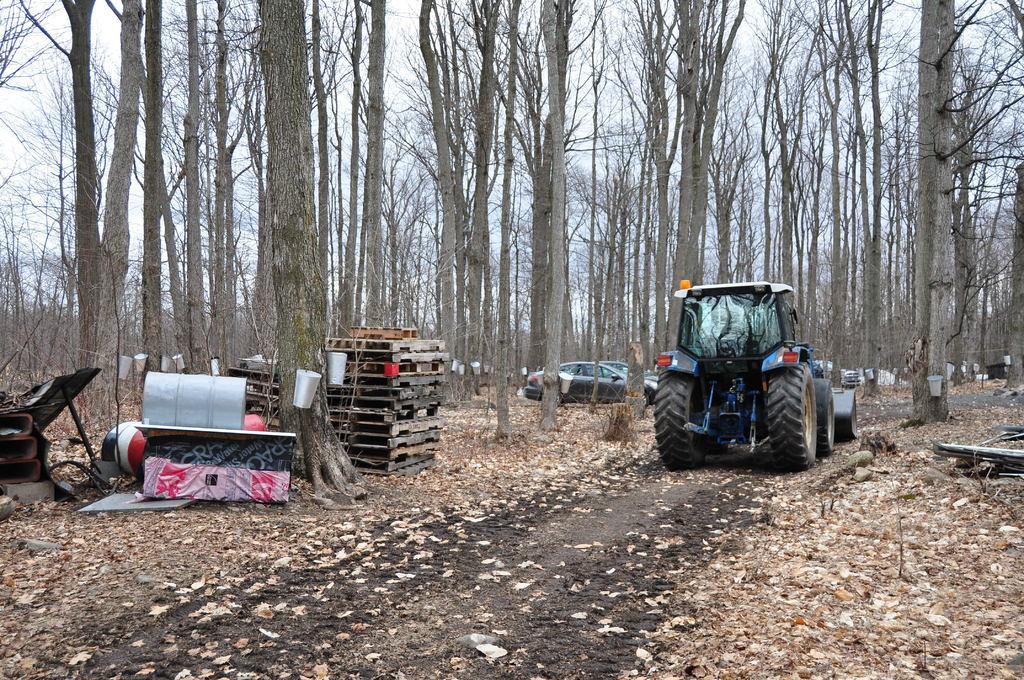Could you give a brief overview of what you see in this image? This image is taken outdoors. At the top of the image there is the sky. At the bottom of the image there is a ground and there are many dry leaves on the ground. In the background there are many trees with stems and branches. A few cars are parked on the ground. On the left side of the image there are a few wooden objects on the ground and there are many metal objects on the ground. In the middle of the image a vehicle is parked on the ground. 